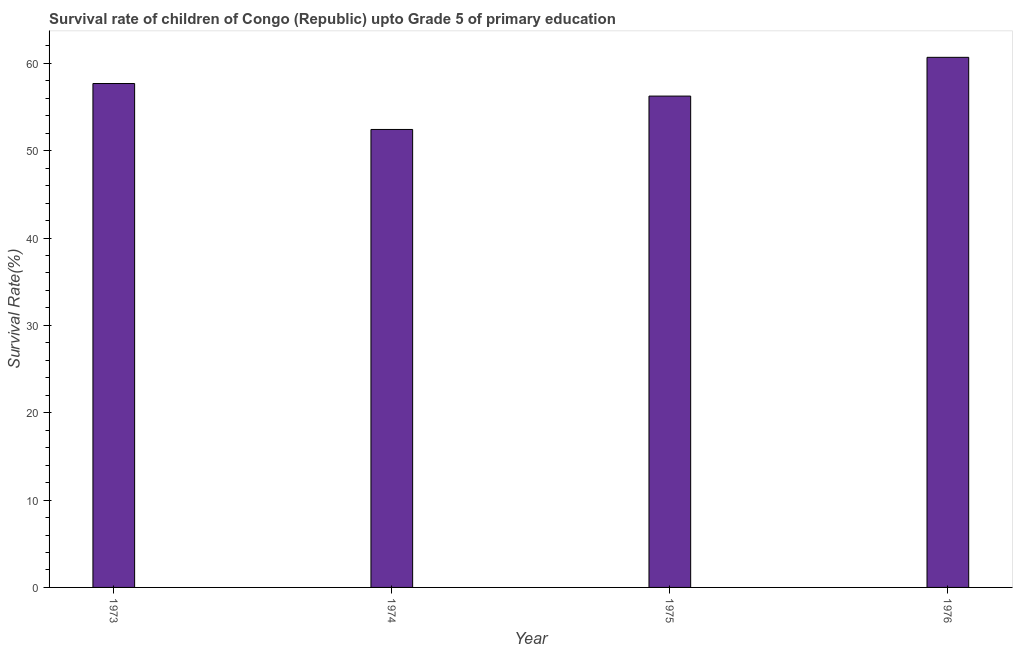Does the graph contain any zero values?
Offer a very short reply. No. What is the title of the graph?
Provide a short and direct response. Survival rate of children of Congo (Republic) upto Grade 5 of primary education. What is the label or title of the Y-axis?
Offer a very short reply. Survival Rate(%). What is the survival rate in 1973?
Provide a short and direct response. 57.69. Across all years, what is the maximum survival rate?
Offer a very short reply. 60.69. Across all years, what is the minimum survival rate?
Make the answer very short. 52.43. In which year was the survival rate maximum?
Provide a short and direct response. 1976. In which year was the survival rate minimum?
Your answer should be compact. 1974. What is the sum of the survival rate?
Ensure brevity in your answer.  227.06. What is the difference between the survival rate in 1973 and 1976?
Make the answer very short. -3. What is the average survival rate per year?
Your answer should be very brief. 56.76. What is the median survival rate?
Give a very brief answer. 56.97. In how many years, is the survival rate greater than 48 %?
Offer a very short reply. 4. Do a majority of the years between 1976 and 1975 (inclusive) have survival rate greater than 22 %?
Provide a short and direct response. No. Is the survival rate in 1973 less than that in 1976?
Your answer should be very brief. Yes. Is the difference between the survival rate in 1974 and 1975 greater than the difference between any two years?
Offer a very short reply. No. What is the difference between the highest and the second highest survival rate?
Give a very brief answer. 3. What is the difference between the highest and the lowest survival rate?
Provide a short and direct response. 8.26. In how many years, is the survival rate greater than the average survival rate taken over all years?
Keep it short and to the point. 2. How many bars are there?
Your answer should be compact. 4. Are all the bars in the graph horizontal?
Your response must be concise. No. How many years are there in the graph?
Ensure brevity in your answer.  4. What is the difference between two consecutive major ticks on the Y-axis?
Provide a short and direct response. 10. Are the values on the major ticks of Y-axis written in scientific E-notation?
Your response must be concise. No. What is the Survival Rate(%) in 1973?
Make the answer very short. 57.69. What is the Survival Rate(%) of 1974?
Your response must be concise. 52.43. What is the Survival Rate(%) in 1975?
Keep it short and to the point. 56.25. What is the Survival Rate(%) of 1976?
Keep it short and to the point. 60.69. What is the difference between the Survival Rate(%) in 1973 and 1974?
Provide a short and direct response. 5.26. What is the difference between the Survival Rate(%) in 1973 and 1975?
Your answer should be compact. 1.44. What is the difference between the Survival Rate(%) in 1973 and 1976?
Ensure brevity in your answer.  -3. What is the difference between the Survival Rate(%) in 1974 and 1975?
Offer a very short reply. -3.82. What is the difference between the Survival Rate(%) in 1974 and 1976?
Keep it short and to the point. -8.26. What is the difference between the Survival Rate(%) in 1975 and 1976?
Your answer should be very brief. -4.44. What is the ratio of the Survival Rate(%) in 1973 to that in 1974?
Ensure brevity in your answer.  1.1. What is the ratio of the Survival Rate(%) in 1973 to that in 1975?
Your answer should be compact. 1.03. What is the ratio of the Survival Rate(%) in 1973 to that in 1976?
Give a very brief answer. 0.95. What is the ratio of the Survival Rate(%) in 1974 to that in 1975?
Ensure brevity in your answer.  0.93. What is the ratio of the Survival Rate(%) in 1974 to that in 1976?
Your answer should be compact. 0.86. What is the ratio of the Survival Rate(%) in 1975 to that in 1976?
Your response must be concise. 0.93. 